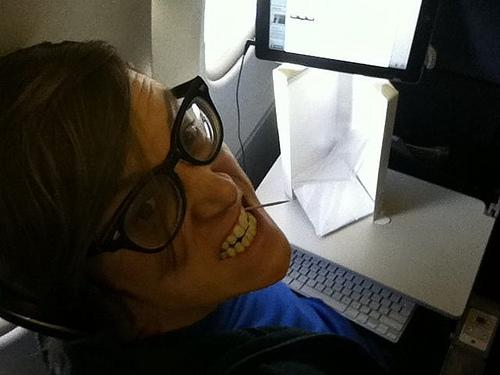What kind of accessory is there on the person's face in the image? There are black framed eyeglasses and thick black glasses on the person's face. Which features of the person's face are visible in the image? An eye, nose, and chin of the person's face are visible, as well as black glasses and hair coming across the eye. Describe any objects or accessories on or near the person's face. The person has black glasses on their face, hair coming across their eye, and toothpick sticking out from their mouth. Give an overall description of the image, including the person, their clothing, and objects around them. A person wearing eyeglasses, a blue shirt, and a blue t-shirt is in the image, with a toothpick in their mouth and yellowish white teeth. There is a gray keyboard, a tablet, a white table top, an airplane window, and several other objects. Describe the accessories and/or objects in the person's mouth. There is a toothpick sticking out of the person's mouth, being held between a set of white teeth. Identify the color and type of clothing worn by the person in the image. The person is wearing a royal blue shirt and a blue t-shirt. What does the person have in their mouth, and what color are their teeth? The person has a toothpick in their mouth and has yellowish white teeth. List three objects that are related to flying or air travel visible in the image. A window of a plane, airplane window open, and a tray sticking out of the chair back. Provide a description of the electronic devices and their accessories in the image. There is a flat screen turned on, a white table top, a grey keyboard, a white and silver keyboard, a tablet screen, headphone jack, and a black cord hanging down. Mention any electronic devices or their components in the image. There are a flat-screen monitor, a white computer keyboard, a grey keyboard, a tablet with its screen and headphone jack, and a black cord. 